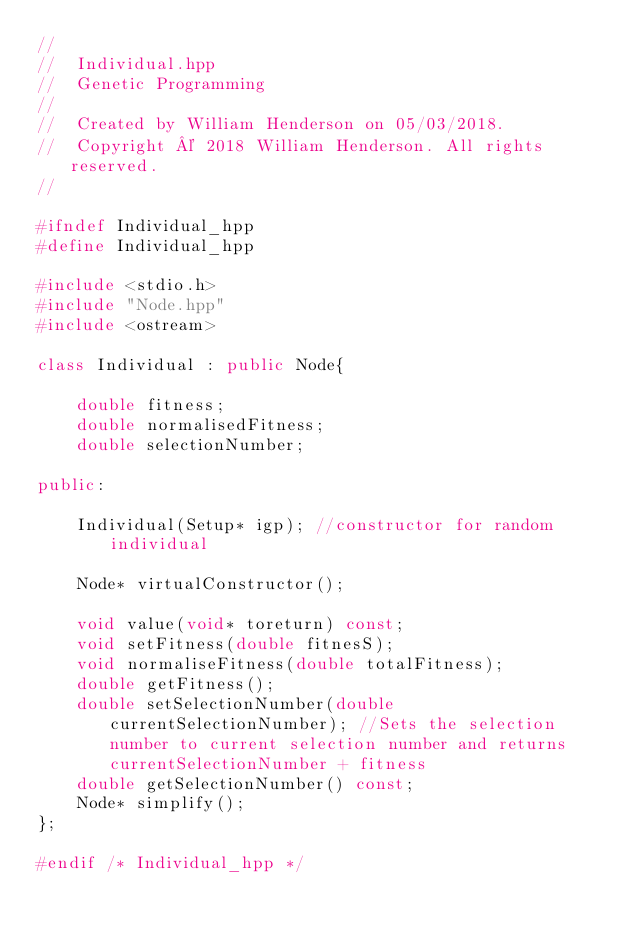<code> <loc_0><loc_0><loc_500><loc_500><_C++_>//
//  Individual.hpp
//  Genetic Programming
//
//  Created by William Henderson on 05/03/2018.
//  Copyright © 2018 William Henderson. All rights reserved.
//

#ifndef Individual_hpp
#define Individual_hpp

#include <stdio.h>
#include "Node.hpp"
#include <ostream>

class Individual : public Node{
    
    double fitness;
    double normalisedFitness;
    double selectionNumber;
    
public:
    
    Individual(Setup* igp); //constructor for random individual
    
    Node* virtualConstructor();
    
    void value(void* toreturn) const;
    void setFitness(double fitnesS);
    void normaliseFitness(double totalFitness);
    double getFitness();
    double setSelectionNumber(double currentSelectionNumber); //Sets the selection number to current selection number and returns currentSelectionNumber + fitness
    double getSelectionNumber() const;
    Node* simplify();
};

#endif /* Individual_hpp */
</code> 